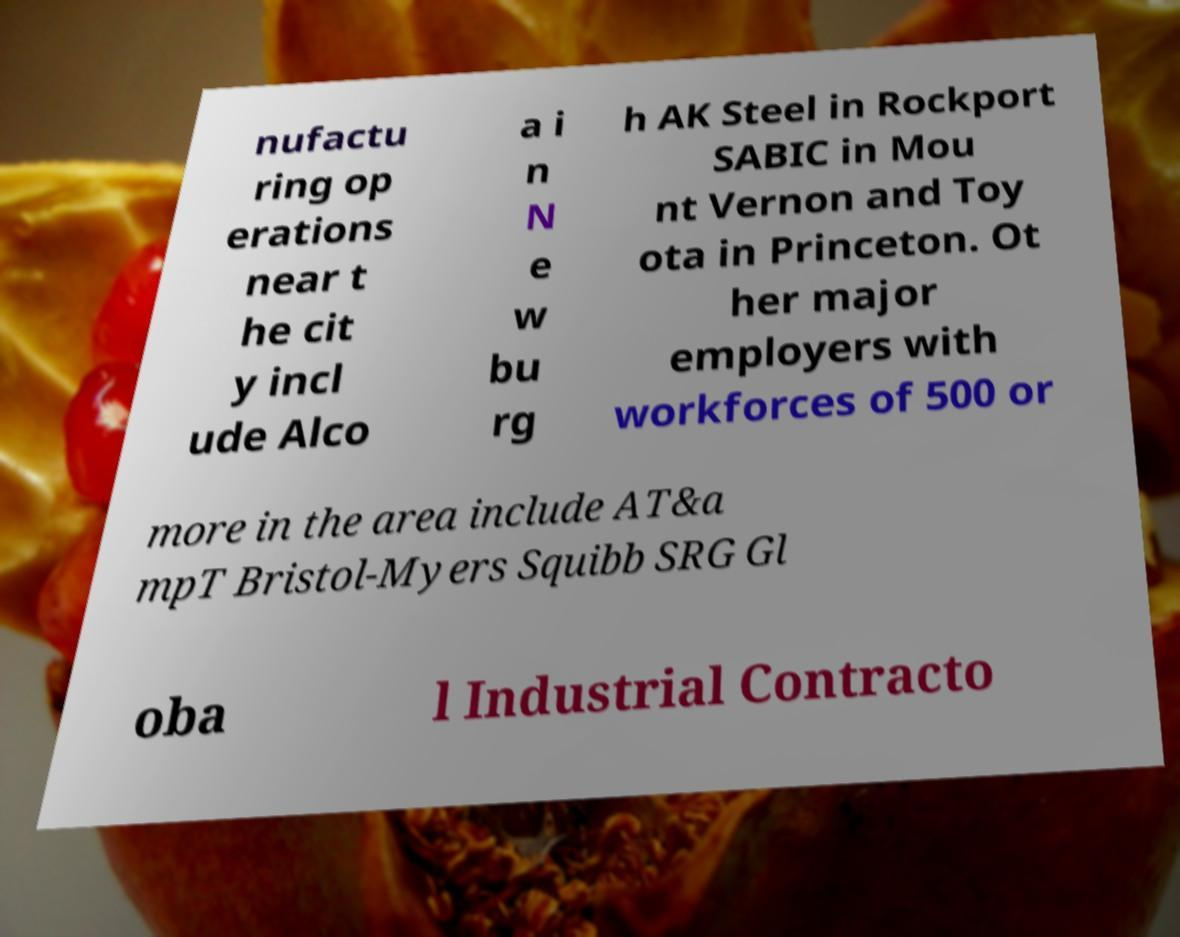There's text embedded in this image that I need extracted. Can you transcribe it verbatim? nufactu ring op erations near t he cit y incl ude Alco a i n N e w bu rg h AK Steel in Rockport SABIC in Mou nt Vernon and Toy ota in Princeton. Ot her major employers with workforces of 500 or more in the area include AT&a mpT Bristol-Myers Squibb SRG Gl oba l Industrial Contracto 